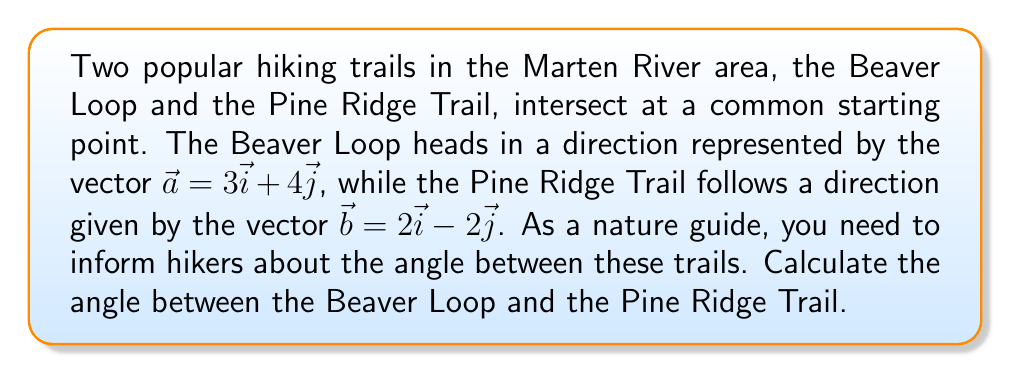Help me with this question. To find the angle between two vectors, we can use the dot product formula:

$$\cos \theta = \frac{\vec{a} \cdot \vec{b}}{|\vec{a}||\vec{b}|}$$

Where $\theta$ is the angle between the vectors, $\vec{a} \cdot \vec{b}$ is the dot product, and $|\vec{a}|$ and $|\vec{b}|$ are the magnitudes of the vectors.

Step 1: Calculate the dot product $\vec{a} \cdot \vec{b}$
$$\vec{a} \cdot \vec{b} = (3)(2) + (4)(-2) = 6 - 8 = -2$$

Step 2: Calculate the magnitudes of $\vec{a}$ and $\vec{b}$
$$|\vec{a}| = \sqrt{3^2 + 4^2} = \sqrt{9 + 16} = \sqrt{25} = 5$$
$$|\vec{b}| = \sqrt{2^2 + (-2)^2} = \sqrt{4 + 4} = \sqrt{8} = 2\sqrt{2}$$

Step 3: Substitute these values into the dot product formula
$$\cos \theta = \frac{-2}{5(2\sqrt{2})} = \frac{-1}{5\sqrt{2}}$$

Step 4: Take the inverse cosine (arccos) of both sides
$$\theta = \arccos(\frac{-1}{5\sqrt{2}})$$

Step 5: Calculate the result (rounded to two decimal places)
$$\theta \approx 1.82 \text{ radians}$$

Convert to degrees:
$$\theta \approx 1.82 \times \frac{180}{\pi} \approx 104.48°$$
Answer: The angle between the Beaver Loop and the Pine Ridge Trail is approximately 104.48°. 